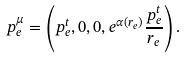<formula> <loc_0><loc_0><loc_500><loc_500>p ^ { \mu } _ { e } = \left ( p ^ { t } _ { e } , 0 , 0 , e ^ { \alpha ( r _ { e } ) } \frac { p ^ { t } _ { e } } { r _ { e } } \right ) .</formula> 